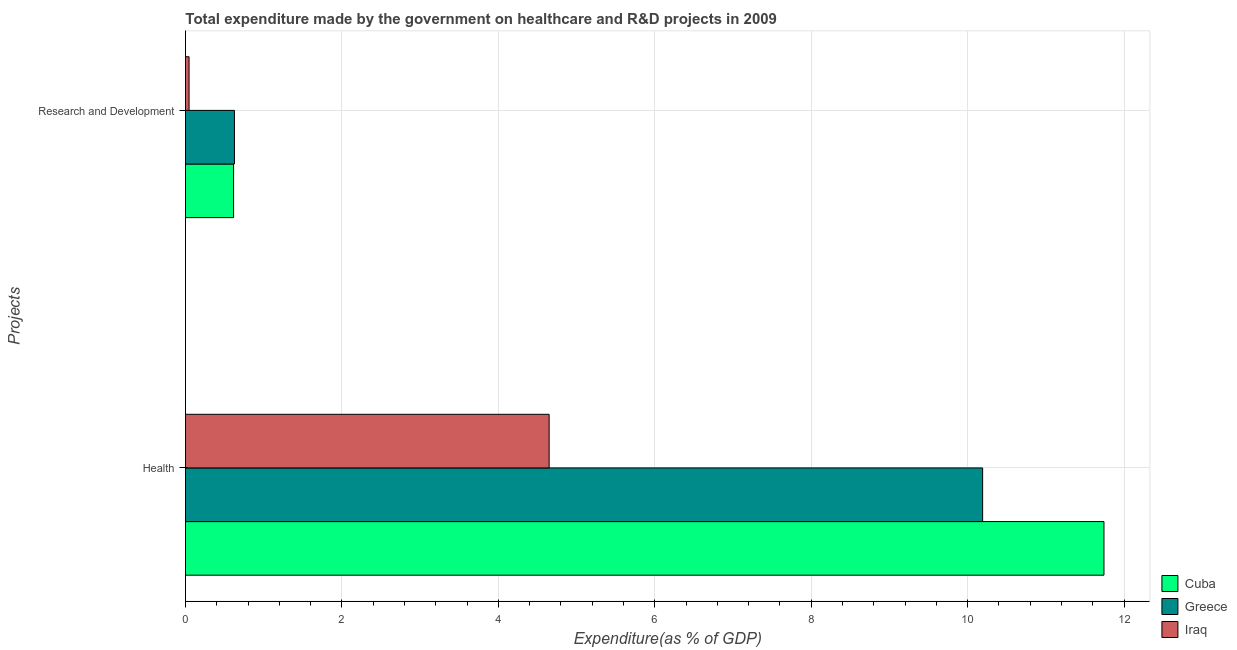How many different coloured bars are there?
Offer a very short reply. 3. How many groups of bars are there?
Offer a very short reply. 2. What is the label of the 2nd group of bars from the top?
Offer a terse response. Health. What is the expenditure in r&d in Greece?
Ensure brevity in your answer.  0.63. Across all countries, what is the maximum expenditure in healthcare?
Your answer should be compact. 11.74. Across all countries, what is the minimum expenditure in healthcare?
Your answer should be very brief. 4.65. In which country was the expenditure in r&d minimum?
Your answer should be compact. Iraq. What is the total expenditure in r&d in the graph?
Your response must be concise. 1.29. What is the difference between the expenditure in healthcare in Cuba and that in Iraq?
Offer a very short reply. 7.09. What is the difference between the expenditure in healthcare in Greece and the expenditure in r&d in Cuba?
Give a very brief answer. 9.58. What is the average expenditure in r&d per country?
Make the answer very short. 0.43. What is the difference between the expenditure in healthcare and expenditure in r&d in Cuba?
Offer a very short reply. 11.13. In how many countries, is the expenditure in r&d greater than 8 %?
Offer a very short reply. 0. What is the ratio of the expenditure in healthcare in Iraq to that in Greece?
Offer a terse response. 0.46. Is the expenditure in healthcare in Cuba less than that in Iraq?
Your answer should be very brief. No. What does the 1st bar from the bottom in Research and Development represents?
Your answer should be very brief. Cuba. How many bars are there?
Your answer should be compact. 6. Are all the bars in the graph horizontal?
Keep it short and to the point. Yes. Are the values on the major ticks of X-axis written in scientific E-notation?
Your answer should be compact. No. Where does the legend appear in the graph?
Offer a very short reply. Bottom right. How many legend labels are there?
Provide a short and direct response. 3. How are the legend labels stacked?
Your response must be concise. Vertical. What is the title of the graph?
Give a very brief answer. Total expenditure made by the government on healthcare and R&D projects in 2009. Does "Greece" appear as one of the legend labels in the graph?
Your response must be concise. Yes. What is the label or title of the X-axis?
Provide a short and direct response. Expenditure(as % of GDP). What is the label or title of the Y-axis?
Ensure brevity in your answer.  Projects. What is the Expenditure(as % of GDP) in Cuba in Health?
Give a very brief answer. 11.74. What is the Expenditure(as % of GDP) of Greece in Health?
Your answer should be compact. 10.19. What is the Expenditure(as % of GDP) of Iraq in Health?
Ensure brevity in your answer.  4.65. What is the Expenditure(as % of GDP) of Cuba in Research and Development?
Ensure brevity in your answer.  0.61. What is the Expenditure(as % of GDP) in Greece in Research and Development?
Make the answer very short. 0.63. What is the Expenditure(as % of GDP) in Iraq in Research and Development?
Ensure brevity in your answer.  0.05. Across all Projects, what is the maximum Expenditure(as % of GDP) of Cuba?
Make the answer very short. 11.74. Across all Projects, what is the maximum Expenditure(as % of GDP) of Greece?
Ensure brevity in your answer.  10.19. Across all Projects, what is the maximum Expenditure(as % of GDP) of Iraq?
Ensure brevity in your answer.  4.65. Across all Projects, what is the minimum Expenditure(as % of GDP) in Cuba?
Your answer should be compact. 0.61. Across all Projects, what is the minimum Expenditure(as % of GDP) in Greece?
Keep it short and to the point. 0.63. Across all Projects, what is the minimum Expenditure(as % of GDP) in Iraq?
Your answer should be very brief. 0.05. What is the total Expenditure(as % of GDP) in Cuba in the graph?
Give a very brief answer. 12.36. What is the total Expenditure(as % of GDP) of Greece in the graph?
Your answer should be compact. 10.82. What is the total Expenditure(as % of GDP) of Iraq in the graph?
Offer a terse response. 4.7. What is the difference between the Expenditure(as % of GDP) in Cuba in Health and that in Research and Development?
Your answer should be compact. 11.13. What is the difference between the Expenditure(as % of GDP) of Greece in Health and that in Research and Development?
Provide a succinct answer. 9.57. What is the difference between the Expenditure(as % of GDP) of Iraq in Health and that in Research and Development?
Give a very brief answer. 4.6. What is the difference between the Expenditure(as % of GDP) in Cuba in Health and the Expenditure(as % of GDP) in Greece in Research and Development?
Your response must be concise. 11.12. What is the difference between the Expenditure(as % of GDP) in Cuba in Health and the Expenditure(as % of GDP) in Iraq in Research and Development?
Give a very brief answer. 11.7. What is the difference between the Expenditure(as % of GDP) of Greece in Health and the Expenditure(as % of GDP) of Iraq in Research and Development?
Keep it short and to the point. 10.15. What is the average Expenditure(as % of GDP) of Cuba per Projects?
Give a very brief answer. 6.18. What is the average Expenditure(as % of GDP) of Greece per Projects?
Provide a short and direct response. 5.41. What is the average Expenditure(as % of GDP) of Iraq per Projects?
Provide a succinct answer. 2.35. What is the difference between the Expenditure(as % of GDP) in Cuba and Expenditure(as % of GDP) in Greece in Health?
Provide a short and direct response. 1.55. What is the difference between the Expenditure(as % of GDP) in Cuba and Expenditure(as % of GDP) in Iraq in Health?
Make the answer very short. 7.09. What is the difference between the Expenditure(as % of GDP) in Greece and Expenditure(as % of GDP) in Iraq in Health?
Make the answer very short. 5.54. What is the difference between the Expenditure(as % of GDP) in Cuba and Expenditure(as % of GDP) in Greece in Research and Development?
Provide a succinct answer. -0.01. What is the difference between the Expenditure(as % of GDP) of Cuba and Expenditure(as % of GDP) of Iraq in Research and Development?
Keep it short and to the point. 0.57. What is the difference between the Expenditure(as % of GDP) of Greece and Expenditure(as % of GDP) of Iraq in Research and Development?
Provide a succinct answer. 0.58. What is the ratio of the Expenditure(as % of GDP) in Cuba in Health to that in Research and Development?
Offer a terse response. 19.1. What is the ratio of the Expenditure(as % of GDP) in Greece in Health to that in Research and Development?
Give a very brief answer. 16.29. What is the ratio of the Expenditure(as % of GDP) of Iraq in Health to that in Research and Development?
Your answer should be compact. 101.92. What is the difference between the highest and the second highest Expenditure(as % of GDP) in Cuba?
Ensure brevity in your answer.  11.13. What is the difference between the highest and the second highest Expenditure(as % of GDP) of Greece?
Provide a short and direct response. 9.57. What is the difference between the highest and the second highest Expenditure(as % of GDP) of Iraq?
Provide a short and direct response. 4.6. What is the difference between the highest and the lowest Expenditure(as % of GDP) of Cuba?
Your answer should be compact. 11.13. What is the difference between the highest and the lowest Expenditure(as % of GDP) of Greece?
Provide a succinct answer. 9.57. What is the difference between the highest and the lowest Expenditure(as % of GDP) of Iraq?
Your answer should be compact. 4.6. 